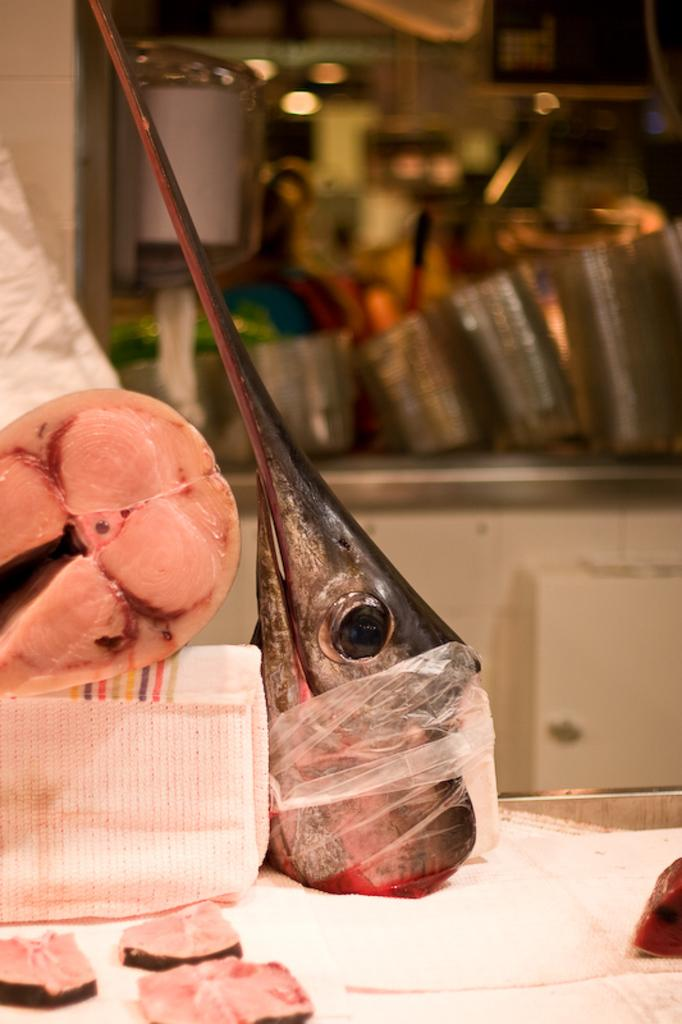What can be seen on the surface in the image? There are fish body parts on the surface in the image. What else is visible in the image besides the fish body parts? In the background of the image, there are utensils. Can you describe the platform on which the utensils are placed? The utensils are on a white color platform. What type of crook can be seen holding the fish body parts in the image? There is no crook present in the image; the fish body parts are simply on the surface. 